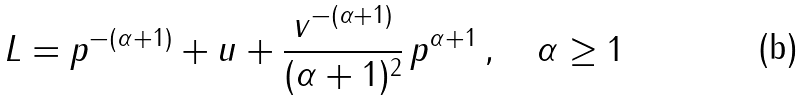Convert formula to latex. <formula><loc_0><loc_0><loc_500><loc_500>L = p ^ { - ( \alpha + 1 ) } + u + { \frac { v ^ { - ( \alpha + 1 ) } } { ( \alpha + 1 ) ^ { 2 } } } \, p ^ { \alpha + 1 } \, , \quad \alpha \geq 1</formula> 